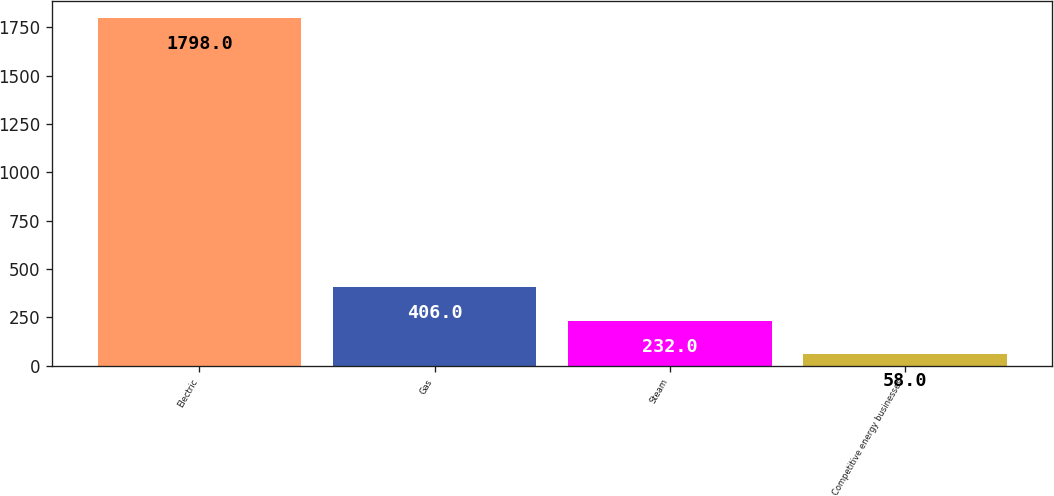<chart> <loc_0><loc_0><loc_500><loc_500><bar_chart><fcel>Electric<fcel>Gas<fcel>Steam<fcel>Competitive energy businesses<nl><fcel>1798<fcel>406<fcel>232<fcel>58<nl></chart> 